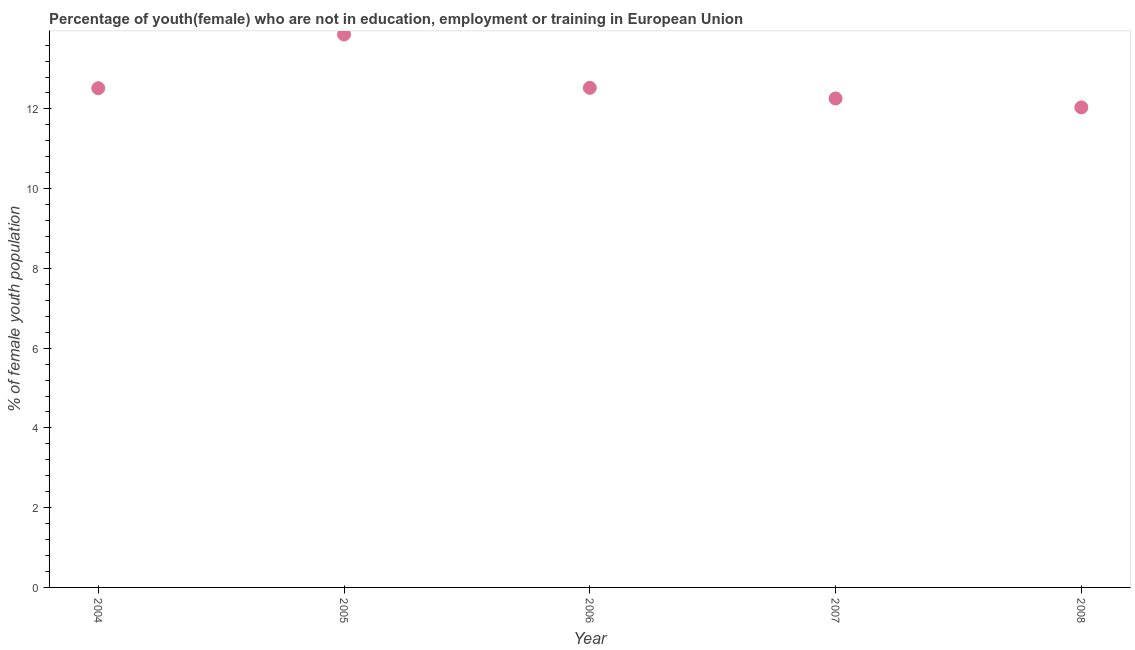What is the unemployed female youth population in 2005?
Offer a terse response. 13.87. Across all years, what is the maximum unemployed female youth population?
Offer a very short reply. 13.87. Across all years, what is the minimum unemployed female youth population?
Provide a succinct answer. 12.04. What is the sum of the unemployed female youth population?
Your answer should be compact. 63.22. What is the difference between the unemployed female youth population in 2005 and 2008?
Your answer should be very brief. 1.83. What is the average unemployed female youth population per year?
Make the answer very short. 12.64. What is the median unemployed female youth population?
Your answer should be compact. 12.52. In how many years, is the unemployed female youth population greater than 8.8 %?
Ensure brevity in your answer.  5. Do a majority of the years between 2005 and 2004 (inclusive) have unemployed female youth population greater than 9.6 %?
Your answer should be very brief. No. What is the ratio of the unemployed female youth population in 2006 to that in 2008?
Your response must be concise. 1.04. Is the difference between the unemployed female youth population in 2004 and 2005 greater than the difference between any two years?
Make the answer very short. No. What is the difference between the highest and the second highest unemployed female youth population?
Your response must be concise. 1.34. Is the sum of the unemployed female youth population in 2006 and 2007 greater than the maximum unemployed female youth population across all years?
Give a very brief answer. Yes. What is the difference between the highest and the lowest unemployed female youth population?
Provide a short and direct response. 1.83. Does the unemployed female youth population monotonically increase over the years?
Offer a terse response. No. How many dotlines are there?
Your answer should be compact. 1. Does the graph contain any zero values?
Your response must be concise. No. What is the title of the graph?
Your answer should be compact. Percentage of youth(female) who are not in education, employment or training in European Union. What is the label or title of the X-axis?
Your answer should be compact. Year. What is the label or title of the Y-axis?
Offer a terse response. % of female youth population. What is the % of female youth population in 2004?
Your response must be concise. 12.52. What is the % of female youth population in 2005?
Offer a very short reply. 13.87. What is the % of female youth population in 2006?
Your response must be concise. 12.53. What is the % of female youth population in 2007?
Your answer should be very brief. 12.26. What is the % of female youth population in 2008?
Keep it short and to the point. 12.04. What is the difference between the % of female youth population in 2004 and 2005?
Ensure brevity in your answer.  -1.35. What is the difference between the % of female youth population in 2004 and 2006?
Offer a very short reply. -0.01. What is the difference between the % of female youth population in 2004 and 2007?
Offer a very short reply. 0.26. What is the difference between the % of female youth population in 2004 and 2008?
Make the answer very short. 0.48. What is the difference between the % of female youth population in 2005 and 2006?
Your response must be concise. 1.34. What is the difference between the % of female youth population in 2005 and 2007?
Your response must be concise. 1.61. What is the difference between the % of female youth population in 2005 and 2008?
Keep it short and to the point. 1.83. What is the difference between the % of female youth population in 2006 and 2007?
Your answer should be very brief. 0.27. What is the difference between the % of female youth population in 2006 and 2008?
Your answer should be compact. 0.49. What is the difference between the % of female youth population in 2007 and 2008?
Make the answer very short. 0.22. What is the ratio of the % of female youth population in 2004 to that in 2005?
Offer a terse response. 0.9. What is the ratio of the % of female youth population in 2004 to that in 2008?
Your response must be concise. 1.04. What is the ratio of the % of female youth population in 2005 to that in 2006?
Your answer should be very brief. 1.11. What is the ratio of the % of female youth population in 2005 to that in 2007?
Your answer should be very brief. 1.13. What is the ratio of the % of female youth population in 2005 to that in 2008?
Give a very brief answer. 1.15. What is the ratio of the % of female youth population in 2006 to that in 2007?
Your answer should be very brief. 1.02. What is the ratio of the % of female youth population in 2006 to that in 2008?
Your response must be concise. 1.04. What is the ratio of the % of female youth population in 2007 to that in 2008?
Your answer should be very brief. 1.02. 